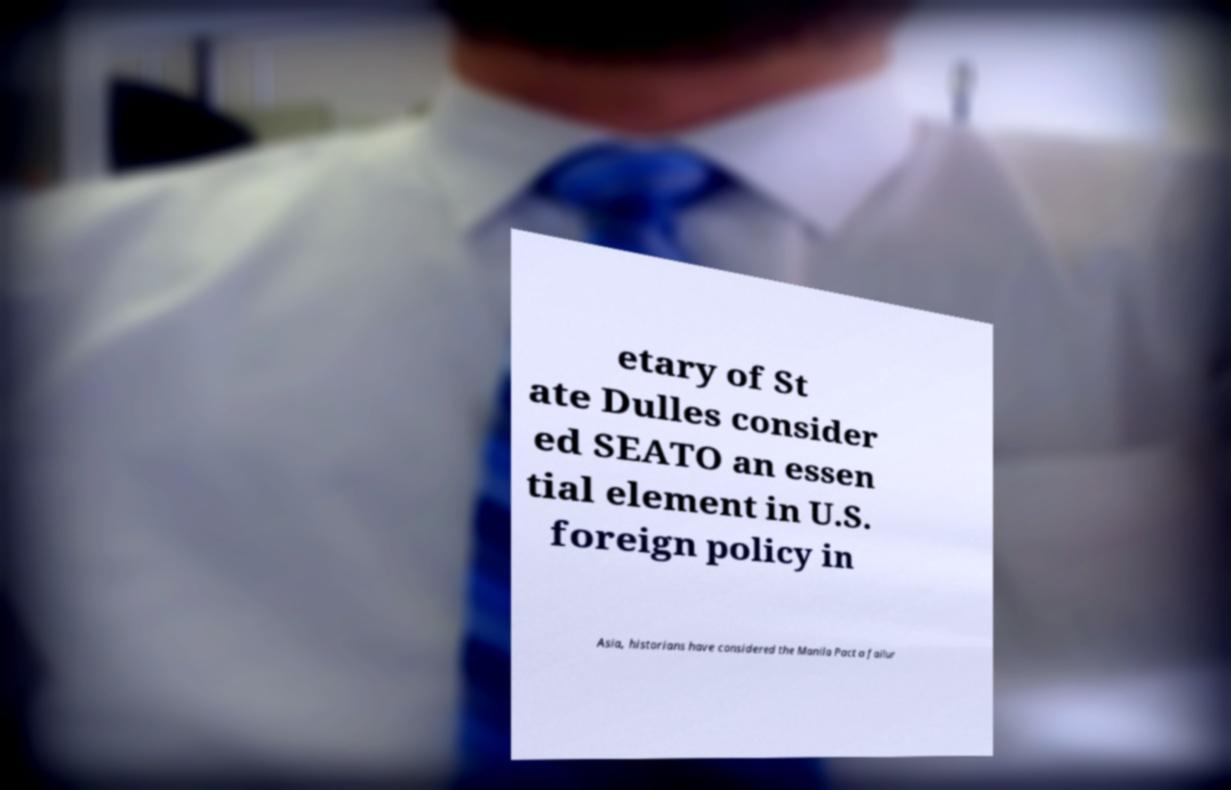Can you read and provide the text displayed in the image?This photo seems to have some interesting text. Can you extract and type it out for me? etary of St ate Dulles consider ed SEATO an essen tial element in U.S. foreign policy in Asia, historians have considered the Manila Pact a failur 